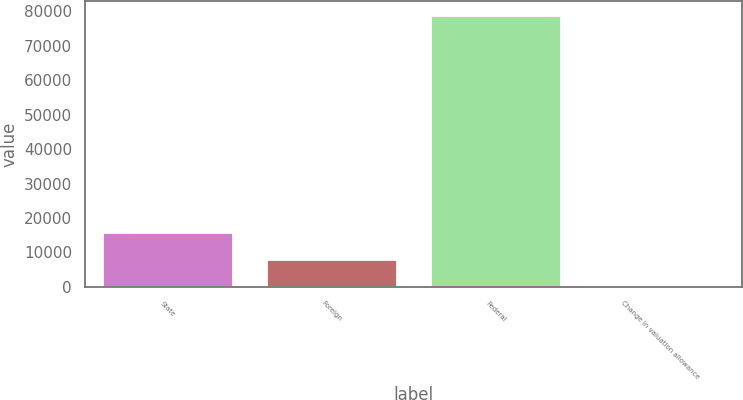Convert chart to OTSL. <chart><loc_0><loc_0><loc_500><loc_500><bar_chart><fcel>State<fcel>Foreign<fcel>Federal<fcel>Change in valuation allowance<nl><fcel>15850.6<fcel>7951.3<fcel>79045<fcel>52<nl></chart> 